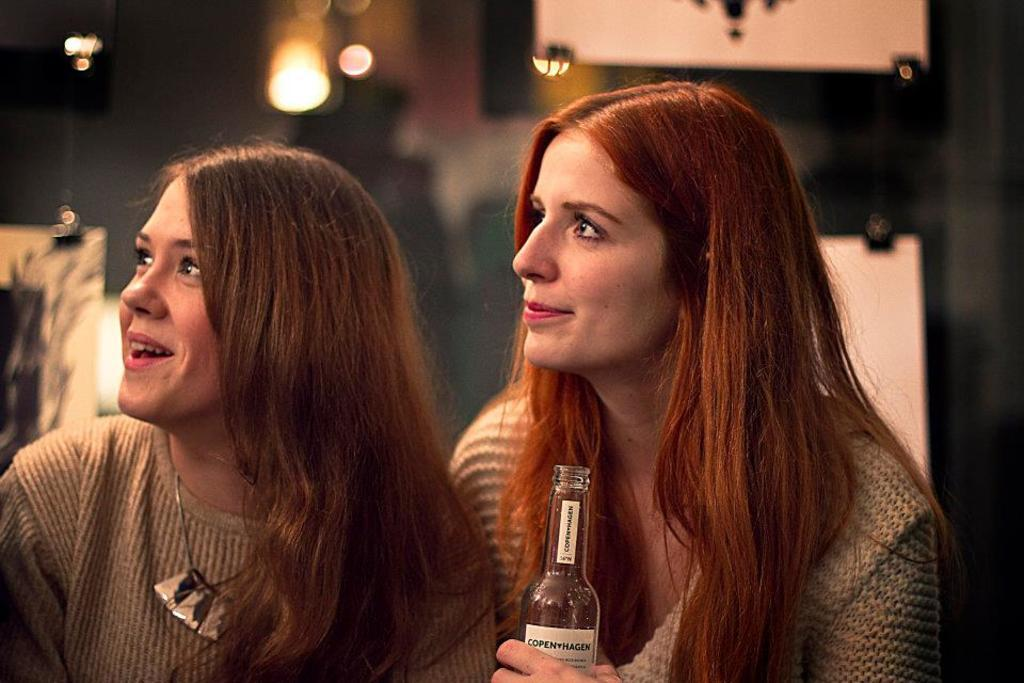How many women are in the image? There are two women in the image. What expressions do the women have? Both women are smiling in the image. What direction are the women looking? The women are looking to the left side of the image. What is one of the women holding? One of the women is holding a bottle. Can you describe the background of the image? The background of the image is blurry. What type of son is the woman meeting in the image? There is no son or meeting present in the image; it features two women looking to the left side of the image. What type of spade is the woman using to dig in the image? There is no spade or digging activity present in the image; it features two women looking to the left side of the image. 